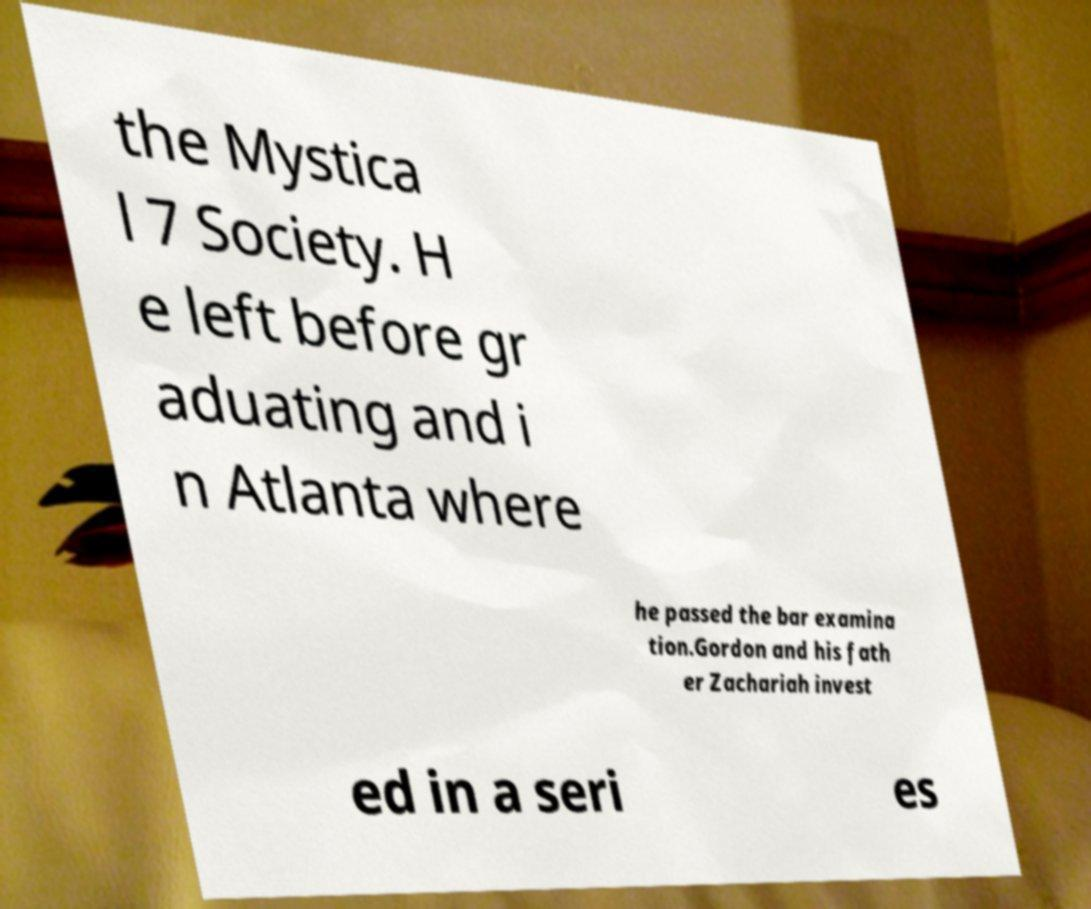What messages or text are displayed in this image? I need them in a readable, typed format. the Mystica l 7 Society. H e left before gr aduating and i n Atlanta where he passed the bar examina tion.Gordon and his fath er Zachariah invest ed in a seri es 